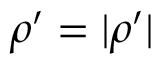<formula> <loc_0><loc_0><loc_500><loc_500>\rho ^ { \prime } = | \rho ^ { \prime } |</formula> 